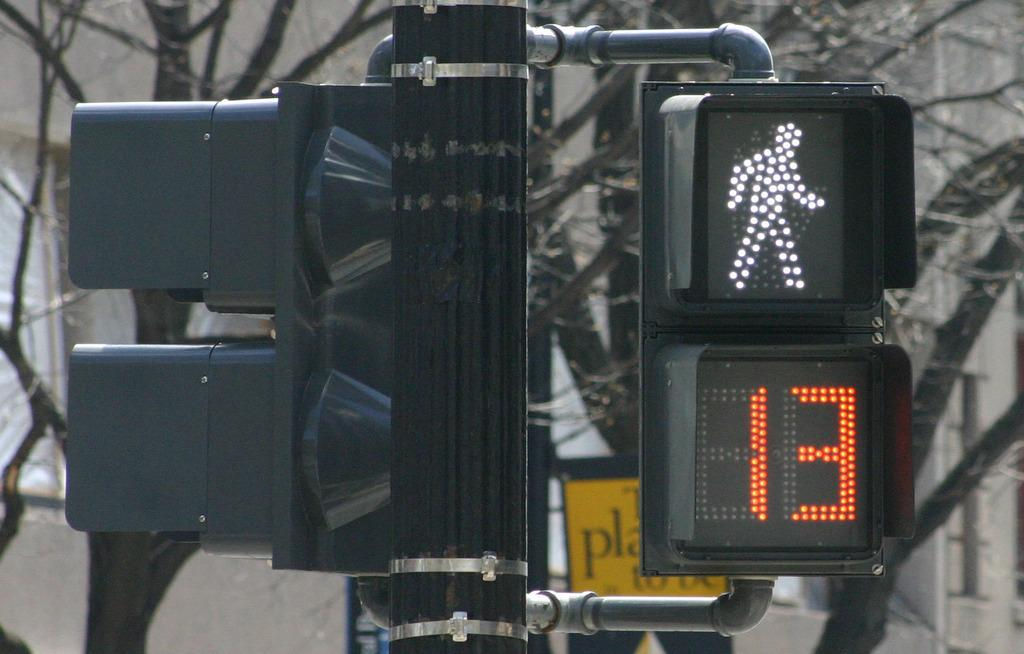<image>
Summarize the visual content of the image. Street sign showing a person walking and the number 13 on it. 